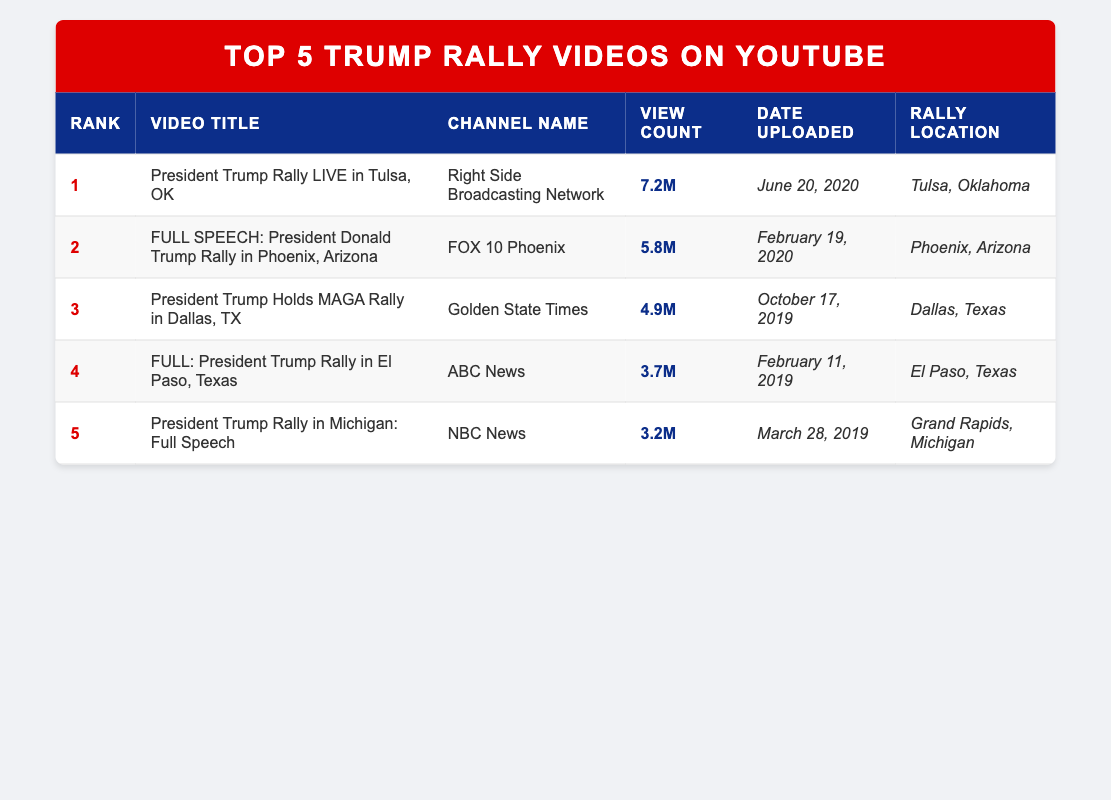What is the title of the most viewed Trump rally video? The most viewed Trump rally video is listed as Rank 1 in the table, which shows the title "President Trump Rally LIVE in Tulsa, OK."
Answer: President Trump Rally LIVE in Tulsa, OK Which channel uploaded the video with the most views? The video with the most views, "President Trump Rally LIVE in Tulsa, OK," was uploaded by "Right Side Broadcasting Network," as seen in the channel name column for Rank 1.
Answer: Right Side Broadcasting Network What was the total view count for the top three videos? The view counts for the top three videos are 7.2M, 5.8M, and 4.9M. Adding them gives 7.2M + 5.8M + 4.9M = 17.9M total views for the top three videos.
Answer: 17.9M Did the rally in Dallas have more views than the rally in El Paso? The Dallas rally video has a view count of 4.9M and the El Paso rally has a view count of 3.7M. Since 4.9M is greater than 3.7M, the Dallas rally did have more views.
Answer: Yes Which rally video was uploaded first? The dates show the El Paso rally was uploaded on February 11, 2019, while all other videos are dated later. Thus, it is the earliest upload among the listed videos.
Answer: FULL: President Trump Rally in El Paso, Texas How many videos were uploaded in March 2019? Upon examining the dates, there is only one video uploaded in March 2019, which is the "President Trump Rally in Michigan: Full Speech" uploaded on March 28, 2019.
Answer: 1 What is the average view count of the top 5 videos? The view counts are 7.2M, 5.8M, 4.9M, 3.7M, and 3.2M. The total is 7.2M + 5.8M + 4.9M + 3.7M + 3.2M = 24.8M. The average is 24.8M / 5 = 4.96M.
Answer: 4.96M Is the Phoenix rally video the only one uploaded by FOX 10 Phoenix? The only video listed from FOX 10 Phoenix is "FULL SPEECH: President Donald Trump Rally in Phoenix, Arizona," indicating it is the only one from that channel in the table.
Answer: Yes 